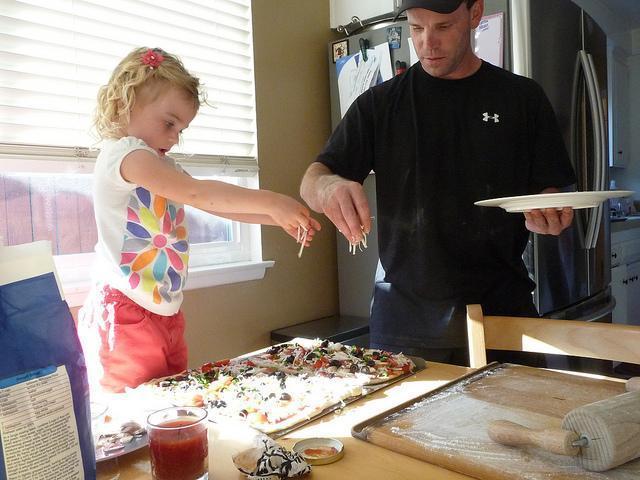How many people are there?
Give a very brief answer. 2. How many red frisbees are airborne?
Give a very brief answer. 0. 